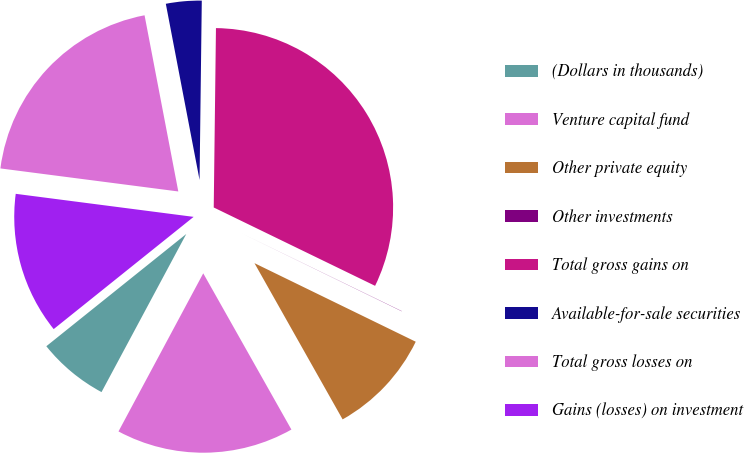<chart> <loc_0><loc_0><loc_500><loc_500><pie_chart><fcel>(Dollars in thousands)<fcel>Venture capital fund<fcel>Other private equity<fcel>Other investments<fcel>Total gross gains on<fcel>Available-for-sale securities<fcel>Total gross losses on<fcel>Gains (losses) on investment<nl><fcel>6.41%<fcel>16.01%<fcel>9.61%<fcel>0.02%<fcel>32.0%<fcel>3.21%<fcel>19.94%<fcel>12.81%<nl></chart> 